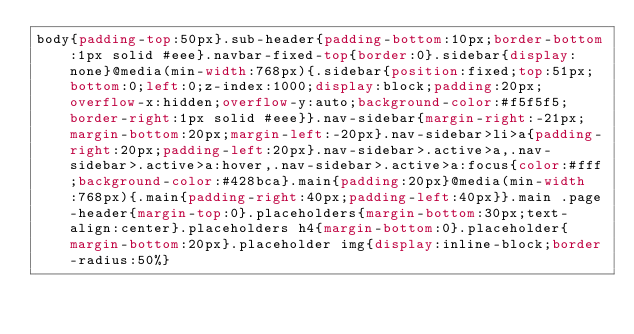<code> <loc_0><loc_0><loc_500><loc_500><_CSS_>body{padding-top:50px}.sub-header{padding-bottom:10px;border-bottom:1px solid #eee}.navbar-fixed-top{border:0}.sidebar{display:none}@media(min-width:768px){.sidebar{position:fixed;top:51px;bottom:0;left:0;z-index:1000;display:block;padding:20px;overflow-x:hidden;overflow-y:auto;background-color:#f5f5f5;border-right:1px solid #eee}}.nav-sidebar{margin-right:-21px;margin-bottom:20px;margin-left:-20px}.nav-sidebar>li>a{padding-right:20px;padding-left:20px}.nav-sidebar>.active>a,.nav-sidebar>.active>a:hover,.nav-sidebar>.active>a:focus{color:#fff;background-color:#428bca}.main{padding:20px}@media(min-width:768px){.main{padding-right:40px;padding-left:40px}}.main .page-header{margin-top:0}.placeholders{margin-bottom:30px;text-align:center}.placeholders h4{margin-bottom:0}.placeholder{margin-bottom:20px}.placeholder img{display:inline-block;border-radius:50%}</code> 